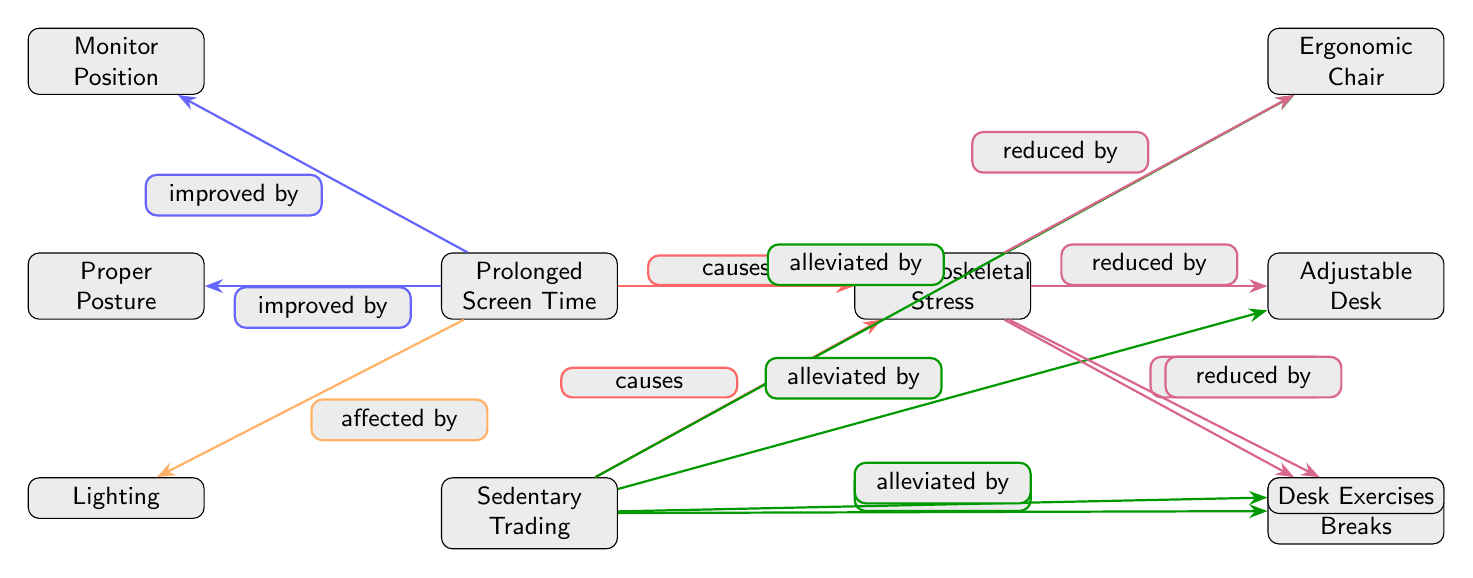What are the two main causes of musculoskeletal stress? The diagram explicitly shows the nodes connected to "Musculoskeletal Stress" with arrows labeled "causes." The two nodes leading to it from "Prolonged Screen Time" and "Sedentary Trading" identify the main causes.
Answer: Prolonged Screen Time, Sedentary Trading How many nodes are related to alleviating factors in the diagram? Counting the nodes that are specifically connected to "Sedentary Trading" with arrows labeled "alleviated by," there are four such nodes: Ergonomic Chair, Adjustable Desk, Frequent Breaks, and Desk Exercises.
Answer: 4 Which factor is improved by proper posture? The diagram has an arrow labeled "improved by" pointing from "Prolonged Screen Time" to "Proper Posture," indicating that proper posture is one of the factors that enhances the situation regarding prolonged screen time.
Answer: Proper Posture What does the "Lighting" node affect? The diagram shows an arrow labeled "affected by" leading from "Prolonged Screen Time" to the "Lighting" node. This indicates that lighting is a factor that can influence prolonged screen time.
Answer: Prolonged Screen Time Which component reduces musculoskeletal stress? The diagram includes multiple arrows leading from "Musculoskeletal Stress" to "Ergonomic Chair," "Adjustable Desk," "Frequent Breaks," and "Desk Exercises," all of which are marked as reducing the stress. Therefore, any of these components would serve as an answer.
Answer: Ergonomic Chair, Adjustable Desk, Frequent Breaks, Desk Exercises How many components can alleviate sedentary trading? By looking at the diagram, I see four nodes connected to "Sedentary Trading" with arrows indicating alleviation, which are Ergonomic Chair, Adjustable Desk, Frequent Breaks, and Desk Exercises.
Answer: 4 What does "Musculoskeletal Stress" relate to? The diagram outlines that "Musculoskeletal Stress" is related directly to "Prolonged Screen Time" and "Sedentary Trading," as shown by the arrows labeled "causes."
Answer: Prolonged Screen Time, Sedentary Trading Which interventions can improve prolonged screen time? The interventions indicated as improvements to "Prolonged Screen Time" are found in the nodes "Monitor Position" and "Proper Posture," linked with the "improved by" arrows.
Answer: Monitor Position, Proper Posture 